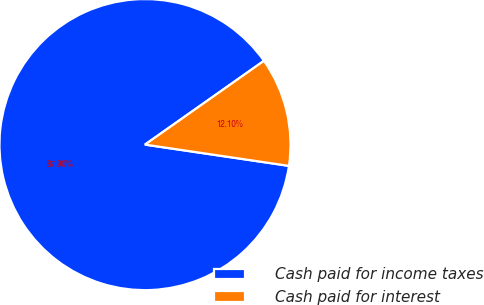<chart> <loc_0><loc_0><loc_500><loc_500><pie_chart><fcel>Cash paid for income taxes<fcel>Cash paid for interest<nl><fcel>87.9%<fcel>12.1%<nl></chart> 